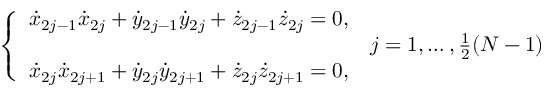Convert formula to latex. <formula><loc_0><loc_0><loc_500><loc_500>\left \{ \begin{array} { l l } { { \dot { x } } _ { 2 j - 1 } { \dot { x } } _ { 2 j } + { \dot { y } } _ { 2 j - 1 } { \dot { y } } _ { 2 j } + { \dot { z } } _ { 2 j - 1 } { \dot { z } } _ { 2 j } = 0 , } & \\ & { j = 1 , \dots , \frac { 1 } { 2 } ( N - 1 ) } \\ { { \dot { x } } _ { 2 j } { \dot { x } } _ { 2 j + 1 } + { \dot { y } } _ { 2 j } { \dot { y } } _ { 2 j + 1 } + { \dot { z } } _ { 2 j } { \dot { z } } _ { 2 j + 1 } = 0 , } \end{array}</formula> 